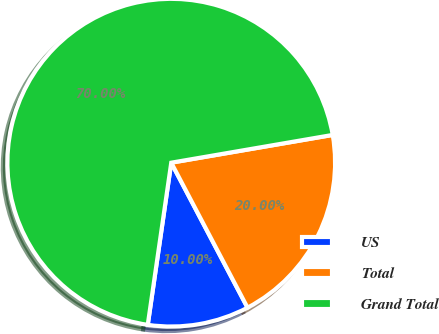Convert chart to OTSL. <chart><loc_0><loc_0><loc_500><loc_500><pie_chart><fcel>US<fcel>Total<fcel>Grand Total<nl><fcel>10.0%<fcel>20.0%<fcel>70.0%<nl></chart> 